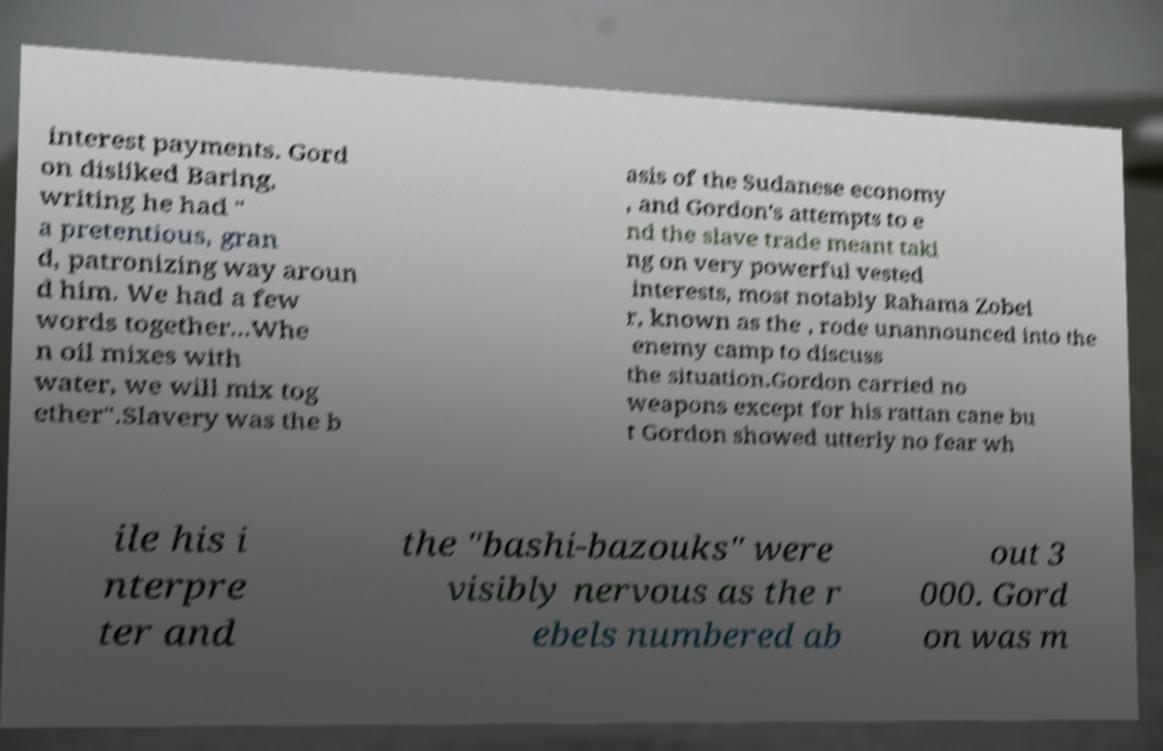What messages or text are displayed in this image? I need them in a readable, typed format. interest payments. Gord on disliked Baring, writing he had " a pretentious, gran d, patronizing way aroun d him. We had a few words together...Whe n oil mixes with water, we will mix tog ether".Slavery was the b asis of the Sudanese economy , and Gordon's attempts to e nd the slave trade meant taki ng on very powerful vested interests, most notably Rahama Zobei r, known as the , rode unannounced into the enemy camp to discuss the situation.Gordon carried no weapons except for his rattan cane bu t Gordon showed utterly no fear wh ile his i nterpre ter and the "bashi-bazouks" were visibly nervous as the r ebels numbered ab out 3 000. Gord on was m 